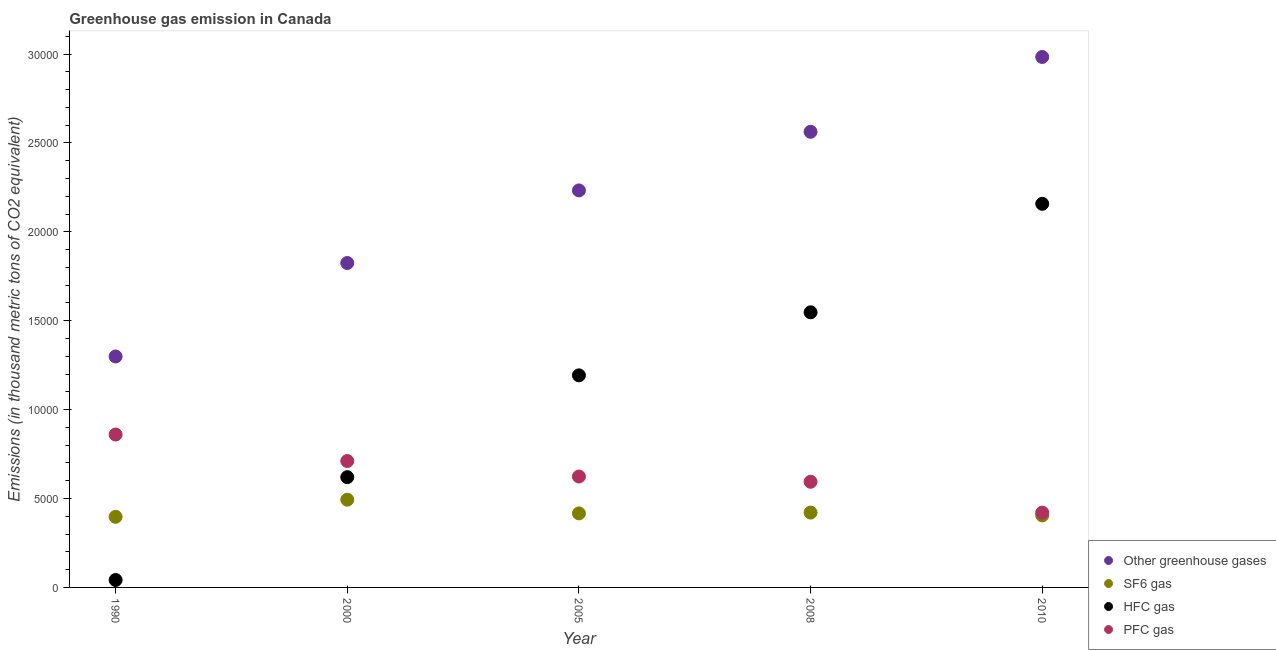How many different coloured dotlines are there?
Your answer should be very brief. 4. What is the emission of greenhouse gases in 2005?
Give a very brief answer. 2.23e+04. Across all years, what is the maximum emission of sf6 gas?
Provide a succinct answer. 4935.1. Across all years, what is the minimum emission of greenhouse gases?
Ensure brevity in your answer.  1.30e+04. In which year was the emission of greenhouse gases maximum?
Make the answer very short. 2010. In which year was the emission of greenhouse gases minimum?
Your answer should be very brief. 1990. What is the total emission of sf6 gas in the graph?
Make the answer very short. 2.13e+04. What is the difference between the emission of sf6 gas in 1990 and that in 2008?
Keep it short and to the point. -237. What is the difference between the emission of hfc gas in 1990 and the emission of sf6 gas in 2008?
Offer a terse response. -3790.3. What is the average emission of hfc gas per year?
Your answer should be very brief. 1.11e+04. In the year 2005, what is the difference between the emission of hfc gas and emission of sf6 gas?
Offer a very short reply. 7764.6. In how many years, is the emission of sf6 gas greater than 28000 thousand metric tons?
Your answer should be compact. 0. What is the ratio of the emission of pfc gas in 1990 to that in 2008?
Your answer should be compact. 1.45. Is the difference between the emission of hfc gas in 1990 and 2000 greater than the difference between the emission of greenhouse gases in 1990 and 2000?
Your answer should be very brief. No. What is the difference between the highest and the second highest emission of sf6 gas?
Ensure brevity in your answer.  726.3. What is the difference between the highest and the lowest emission of hfc gas?
Your answer should be very brief. 2.12e+04. In how many years, is the emission of hfc gas greater than the average emission of hfc gas taken over all years?
Offer a terse response. 3. How many dotlines are there?
Ensure brevity in your answer.  4. How are the legend labels stacked?
Your response must be concise. Vertical. What is the title of the graph?
Your answer should be very brief. Greenhouse gas emission in Canada. What is the label or title of the Y-axis?
Your response must be concise. Emissions (in thousand metric tons of CO2 equivalent). What is the Emissions (in thousand metric tons of CO2 equivalent) in Other greenhouse gases in 1990?
Your answer should be very brief. 1.30e+04. What is the Emissions (in thousand metric tons of CO2 equivalent) in SF6 gas in 1990?
Provide a succinct answer. 3971.8. What is the Emissions (in thousand metric tons of CO2 equivalent) of HFC gas in 1990?
Provide a succinct answer. 418.5. What is the Emissions (in thousand metric tons of CO2 equivalent) of PFC gas in 1990?
Provide a succinct answer. 8600.3. What is the Emissions (in thousand metric tons of CO2 equivalent) of Other greenhouse gases in 2000?
Offer a very short reply. 1.82e+04. What is the Emissions (in thousand metric tons of CO2 equivalent) of SF6 gas in 2000?
Give a very brief answer. 4935.1. What is the Emissions (in thousand metric tons of CO2 equivalent) of HFC gas in 2000?
Keep it short and to the point. 6202.8. What is the Emissions (in thousand metric tons of CO2 equivalent) of PFC gas in 2000?
Your response must be concise. 7109.9. What is the Emissions (in thousand metric tons of CO2 equivalent) in Other greenhouse gases in 2005?
Offer a very short reply. 2.23e+04. What is the Emissions (in thousand metric tons of CO2 equivalent) in SF6 gas in 2005?
Your answer should be very brief. 4163.8. What is the Emissions (in thousand metric tons of CO2 equivalent) of HFC gas in 2005?
Provide a short and direct response. 1.19e+04. What is the Emissions (in thousand metric tons of CO2 equivalent) of PFC gas in 2005?
Keep it short and to the point. 6238. What is the Emissions (in thousand metric tons of CO2 equivalent) in Other greenhouse gases in 2008?
Provide a succinct answer. 2.56e+04. What is the Emissions (in thousand metric tons of CO2 equivalent) of SF6 gas in 2008?
Your answer should be compact. 4208.8. What is the Emissions (in thousand metric tons of CO2 equivalent) of HFC gas in 2008?
Offer a very short reply. 1.55e+04. What is the Emissions (in thousand metric tons of CO2 equivalent) in PFC gas in 2008?
Make the answer very short. 5943.7. What is the Emissions (in thousand metric tons of CO2 equivalent) of Other greenhouse gases in 2010?
Ensure brevity in your answer.  2.98e+04. What is the Emissions (in thousand metric tons of CO2 equivalent) in SF6 gas in 2010?
Your answer should be very brief. 4050. What is the Emissions (in thousand metric tons of CO2 equivalent) of HFC gas in 2010?
Your response must be concise. 2.16e+04. What is the Emissions (in thousand metric tons of CO2 equivalent) in PFC gas in 2010?
Keep it short and to the point. 4209. Across all years, what is the maximum Emissions (in thousand metric tons of CO2 equivalent) in Other greenhouse gases?
Your answer should be very brief. 2.98e+04. Across all years, what is the maximum Emissions (in thousand metric tons of CO2 equivalent) of SF6 gas?
Your answer should be compact. 4935.1. Across all years, what is the maximum Emissions (in thousand metric tons of CO2 equivalent) of HFC gas?
Give a very brief answer. 2.16e+04. Across all years, what is the maximum Emissions (in thousand metric tons of CO2 equivalent) of PFC gas?
Offer a very short reply. 8600.3. Across all years, what is the minimum Emissions (in thousand metric tons of CO2 equivalent) of Other greenhouse gases?
Offer a very short reply. 1.30e+04. Across all years, what is the minimum Emissions (in thousand metric tons of CO2 equivalent) in SF6 gas?
Provide a succinct answer. 3971.8. Across all years, what is the minimum Emissions (in thousand metric tons of CO2 equivalent) in HFC gas?
Your answer should be compact. 418.5. Across all years, what is the minimum Emissions (in thousand metric tons of CO2 equivalent) in PFC gas?
Provide a short and direct response. 4209. What is the total Emissions (in thousand metric tons of CO2 equivalent) in Other greenhouse gases in the graph?
Make the answer very short. 1.09e+05. What is the total Emissions (in thousand metric tons of CO2 equivalent) of SF6 gas in the graph?
Your response must be concise. 2.13e+04. What is the total Emissions (in thousand metric tons of CO2 equivalent) of HFC gas in the graph?
Provide a short and direct response. 5.56e+04. What is the total Emissions (in thousand metric tons of CO2 equivalent) in PFC gas in the graph?
Provide a short and direct response. 3.21e+04. What is the difference between the Emissions (in thousand metric tons of CO2 equivalent) in Other greenhouse gases in 1990 and that in 2000?
Make the answer very short. -5257.2. What is the difference between the Emissions (in thousand metric tons of CO2 equivalent) of SF6 gas in 1990 and that in 2000?
Ensure brevity in your answer.  -963.3. What is the difference between the Emissions (in thousand metric tons of CO2 equivalent) of HFC gas in 1990 and that in 2000?
Your answer should be very brief. -5784.3. What is the difference between the Emissions (in thousand metric tons of CO2 equivalent) in PFC gas in 1990 and that in 2000?
Offer a very short reply. 1490.4. What is the difference between the Emissions (in thousand metric tons of CO2 equivalent) of Other greenhouse gases in 1990 and that in 2005?
Offer a very short reply. -9339.6. What is the difference between the Emissions (in thousand metric tons of CO2 equivalent) in SF6 gas in 1990 and that in 2005?
Make the answer very short. -192. What is the difference between the Emissions (in thousand metric tons of CO2 equivalent) of HFC gas in 1990 and that in 2005?
Your answer should be compact. -1.15e+04. What is the difference between the Emissions (in thousand metric tons of CO2 equivalent) of PFC gas in 1990 and that in 2005?
Your answer should be very brief. 2362.3. What is the difference between the Emissions (in thousand metric tons of CO2 equivalent) in Other greenhouse gases in 1990 and that in 2008?
Provide a short and direct response. -1.26e+04. What is the difference between the Emissions (in thousand metric tons of CO2 equivalent) in SF6 gas in 1990 and that in 2008?
Offer a very short reply. -237. What is the difference between the Emissions (in thousand metric tons of CO2 equivalent) in HFC gas in 1990 and that in 2008?
Keep it short and to the point. -1.51e+04. What is the difference between the Emissions (in thousand metric tons of CO2 equivalent) in PFC gas in 1990 and that in 2008?
Keep it short and to the point. 2656.6. What is the difference between the Emissions (in thousand metric tons of CO2 equivalent) in Other greenhouse gases in 1990 and that in 2010?
Your response must be concise. -1.68e+04. What is the difference between the Emissions (in thousand metric tons of CO2 equivalent) of SF6 gas in 1990 and that in 2010?
Offer a very short reply. -78.2. What is the difference between the Emissions (in thousand metric tons of CO2 equivalent) of HFC gas in 1990 and that in 2010?
Provide a succinct answer. -2.12e+04. What is the difference between the Emissions (in thousand metric tons of CO2 equivalent) of PFC gas in 1990 and that in 2010?
Your answer should be very brief. 4391.3. What is the difference between the Emissions (in thousand metric tons of CO2 equivalent) in Other greenhouse gases in 2000 and that in 2005?
Offer a very short reply. -4082.4. What is the difference between the Emissions (in thousand metric tons of CO2 equivalent) in SF6 gas in 2000 and that in 2005?
Your response must be concise. 771.3. What is the difference between the Emissions (in thousand metric tons of CO2 equivalent) of HFC gas in 2000 and that in 2005?
Offer a terse response. -5725.6. What is the difference between the Emissions (in thousand metric tons of CO2 equivalent) of PFC gas in 2000 and that in 2005?
Give a very brief answer. 871.9. What is the difference between the Emissions (in thousand metric tons of CO2 equivalent) in Other greenhouse gases in 2000 and that in 2008?
Offer a very short reply. -7379.5. What is the difference between the Emissions (in thousand metric tons of CO2 equivalent) of SF6 gas in 2000 and that in 2008?
Your answer should be very brief. 726.3. What is the difference between the Emissions (in thousand metric tons of CO2 equivalent) in HFC gas in 2000 and that in 2008?
Give a very brief answer. -9272. What is the difference between the Emissions (in thousand metric tons of CO2 equivalent) in PFC gas in 2000 and that in 2008?
Give a very brief answer. 1166.2. What is the difference between the Emissions (in thousand metric tons of CO2 equivalent) of Other greenhouse gases in 2000 and that in 2010?
Ensure brevity in your answer.  -1.16e+04. What is the difference between the Emissions (in thousand metric tons of CO2 equivalent) in SF6 gas in 2000 and that in 2010?
Offer a terse response. 885.1. What is the difference between the Emissions (in thousand metric tons of CO2 equivalent) in HFC gas in 2000 and that in 2010?
Your response must be concise. -1.54e+04. What is the difference between the Emissions (in thousand metric tons of CO2 equivalent) in PFC gas in 2000 and that in 2010?
Your answer should be compact. 2900.9. What is the difference between the Emissions (in thousand metric tons of CO2 equivalent) of Other greenhouse gases in 2005 and that in 2008?
Your answer should be very brief. -3297.1. What is the difference between the Emissions (in thousand metric tons of CO2 equivalent) of SF6 gas in 2005 and that in 2008?
Ensure brevity in your answer.  -45. What is the difference between the Emissions (in thousand metric tons of CO2 equivalent) of HFC gas in 2005 and that in 2008?
Provide a short and direct response. -3546.4. What is the difference between the Emissions (in thousand metric tons of CO2 equivalent) of PFC gas in 2005 and that in 2008?
Your answer should be compact. 294.3. What is the difference between the Emissions (in thousand metric tons of CO2 equivalent) of Other greenhouse gases in 2005 and that in 2010?
Offer a terse response. -7505.8. What is the difference between the Emissions (in thousand metric tons of CO2 equivalent) of SF6 gas in 2005 and that in 2010?
Make the answer very short. 113.8. What is the difference between the Emissions (in thousand metric tons of CO2 equivalent) of HFC gas in 2005 and that in 2010?
Make the answer very short. -9648.6. What is the difference between the Emissions (in thousand metric tons of CO2 equivalent) in PFC gas in 2005 and that in 2010?
Keep it short and to the point. 2029. What is the difference between the Emissions (in thousand metric tons of CO2 equivalent) of Other greenhouse gases in 2008 and that in 2010?
Your response must be concise. -4208.7. What is the difference between the Emissions (in thousand metric tons of CO2 equivalent) of SF6 gas in 2008 and that in 2010?
Your response must be concise. 158.8. What is the difference between the Emissions (in thousand metric tons of CO2 equivalent) in HFC gas in 2008 and that in 2010?
Your response must be concise. -6102.2. What is the difference between the Emissions (in thousand metric tons of CO2 equivalent) of PFC gas in 2008 and that in 2010?
Give a very brief answer. 1734.7. What is the difference between the Emissions (in thousand metric tons of CO2 equivalent) in Other greenhouse gases in 1990 and the Emissions (in thousand metric tons of CO2 equivalent) in SF6 gas in 2000?
Your answer should be compact. 8055.5. What is the difference between the Emissions (in thousand metric tons of CO2 equivalent) in Other greenhouse gases in 1990 and the Emissions (in thousand metric tons of CO2 equivalent) in HFC gas in 2000?
Make the answer very short. 6787.8. What is the difference between the Emissions (in thousand metric tons of CO2 equivalent) in Other greenhouse gases in 1990 and the Emissions (in thousand metric tons of CO2 equivalent) in PFC gas in 2000?
Your answer should be compact. 5880.7. What is the difference between the Emissions (in thousand metric tons of CO2 equivalent) in SF6 gas in 1990 and the Emissions (in thousand metric tons of CO2 equivalent) in HFC gas in 2000?
Ensure brevity in your answer.  -2231. What is the difference between the Emissions (in thousand metric tons of CO2 equivalent) of SF6 gas in 1990 and the Emissions (in thousand metric tons of CO2 equivalent) of PFC gas in 2000?
Offer a terse response. -3138.1. What is the difference between the Emissions (in thousand metric tons of CO2 equivalent) of HFC gas in 1990 and the Emissions (in thousand metric tons of CO2 equivalent) of PFC gas in 2000?
Your answer should be very brief. -6691.4. What is the difference between the Emissions (in thousand metric tons of CO2 equivalent) of Other greenhouse gases in 1990 and the Emissions (in thousand metric tons of CO2 equivalent) of SF6 gas in 2005?
Offer a very short reply. 8826.8. What is the difference between the Emissions (in thousand metric tons of CO2 equivalent) of Other greenhouse gases in 1990 and the Emissions (in thousand metric tons of CO2 equivalent) of HFC gas in 2005?
Ensure brevity in your answer.  1062.2. What is the difference between the Emissions (in thousand metric tons of CO2 equivalent) of Other greenhouse gases in 1990 and the Emissions (in thousand metric tons of CO2 equivalent) of PFC gas in 2005?
Provide a succinct answer. 6752.6. What is the difference between the Emissions (in thousand metric tons of CO2 equivalent) of SF6 gas in 1990 and the Emissions (in thousand metric tons of CO2 equivalent) of HFC gas in 2005?
Your answer should be compact. -7956.6. What is the difference between the Emissions (in thousand metric tons of CO2 equivalent) of SF6 gas in 1990 and the Emissions (in thousand metric tons of CO2 equivalent) of PFC gas in 2005?
Make the answer very short. -2266.2. What is the difference between the Emissions (in thousand metric tons of CO2 equivalent) in HFC gas in 1990 and the Emissions (in thousand metric tons of CO2 equivalent) in PFC gas in 2005?
Offer a very short reply. -5819.5. What is the difference between the Emissions (in thousand metric tons of CO2 equivalent) in Other greenhouse gases in 1990 and the Emissions (in thousand metric tons of CO2 equivalent) in SF6 gas in 2008?
Provide a short and direct response. 8781.8. What is the difference between the Emissions (in thousand metric tons of CO2 equivalent) of Other greenhouse gases in 1990 and the Emissions (in thousand metric tons of CO2 equivalent) of HFC gas in 2008?
Offer a terse response. -2484.2. What is the difference between the Emissions (in thousand metric tons of CO2 equivalent) in Other greenhouse gases in 1990 and the Emissions (in thousand metric tons of CO2 equivalent) in PFC gas in 2008?
Your answer should be very brief. 7046.9. What is the difference between the Emissions (in thousand metric tons of CO2 equivalent) in SF6 gas in 1990 and the Emissions (in thousand metric tons of CO2 equivalent) in HFC gas in 2008?
Give a very brief answer. -1.15e+04. What is the difference between the Emissions (in thousand metric tons of CO2 equivalent) of SF6 gas in 1990 and the Emissions (in thousand metric tons of CO2 equivalent) of PFC gas in 2008?
Your response must be concise. -1971.9. What is the difference between the Emissions (in thousand metric tons of CO2 equivalent) of HFC gas in 1990 and the Emissions (in thousand metric tons of CO2 equivalent) of PFC gas in 2008?
Make the answer very short. -5525.2. What is the difference between the Emissions (in thousand metric tons of CO2 equivalent) in Other greenhouse gases in 1990 and the Emissions (in thousand metric tons of CO2 equivalent) in SF6 gas in 2010?
Your answer should be compact. 8940.6. What is the difference between the Emissions (in thousand metric tons of CO2 equivalent) of Other greenhouse gases in 1990 and the Emissions (in thousand metric tons of CO2 equivalent) of HFC gas in 2010?
Make the answer very short. -8586.4. What is the difference between the Emissions (in thousand metric tons of CO2 equivalent) in Other greenhouse gases in 1990 and the Emissions (in thousand metric tons of CO2 equivalent) in PFC gas in 2010?
Ensure brevity in your answer.  8781.6. What is the difference between the Emissions (in thousand metric tons of CO2 equivalent) in SF6 gas in 1990 and the Emissions (in thousand metric tons of CO2 equivalent) in HFC gas in 2010?
Offer a very short reply. -1.76e+04. What is the difference between the Emissions (in thousand metric tons of CO2 equivalent) in SF6 gas in 1990 and the Emissions (in thousand metric tons of CO2 equivalent) in PFC gas in 2010?
Keep it short and to the point. -237.2. What is the difference between the Emissions (in thousand metric tons of CO2 equivalent) of HFC gas in 1990 and the Emissions (in thousand metric tons of CO2 equivalent) of PFC gas in 2010?
Your answer should be compact. -3790.5. What is the difference between the Emissions (in thousand metric tons of CO2 equivalent) of Other greenhouse gases in 2000 and the Emissions (in thousand metric tons of CO2 equivalent) of SF6 gas in 2005?
Offer a very short reply. 1.41e+04. What is the difference between the Emissions (in thousand metric tons of CO2 equivalent) in Other greenhouse gases in 2000 and the Emissions (in thousand metric tons of CO2 equivalent) in HFC gas in 2005?
Your answer should be compact. 6319.4. What is the difference between the Emissions (in thousand metric tons of CO2 equivalent) in Other greenhouse gases in 2000 and the Emissions (in thousand metric tons of CO2 equivalent) in PFC gas in 2005?
Offer a terse response. 1.20e+04. What is the difference between the Emissions (in thousand metric tons of CO2 equivalent) in SF6 gas in 2000 and the Emissions (in thousand metric tons of CO2 equivalent) in HFC gas in 2005?
Provide a succinct answer. -6993.3. What is the difference between the Emissions (in thousand metric tons of CO2 equivalent) of SF6 gas in 2000 and the Emissions (in thousand metric tons of CO2 equivalent) of PFC gas in 2005?
Keep it short and to the point. -1302.9. What is the difference between the Emissions (in thousand metric tons of CO2 equivalent) of HFC gas in 2000 and the Emissions (in thousand metric tons of CO2 equivalent) of PFC gas in 2005?
Give a very brief answer. -35.2. What is the difference between the Emissions (in thousand metric tons of CO2 equivalent) in Other greenhouse gases in 2000 and the Emissions (in thousand metric tons of CO2 equivalent) in SF6 gas in 2008?
Provide a succinct answer. 1.40e+04. What is the difference between the Emissions (in thousand metric tons of CO2 equivalent) of Other greenhouse gases in 2000 and the Emissions (in thousand metric tons of CO2 equivalent) of HFC gas in 2008?
Your response must be concise. 2773. What is the difference between the Emissions (in thousand metric tons of CO2 equivalent) of Other greenhouse gases in 2000 and the Emissions (in thousand metric tons of CO2 equivalent) of PFC gas in 2008?
Your response must be concise. 1.23e+04. What is the difference between the Emissions (in thousand metric tons of CO2 equivalent) of SF6 gas in 2000 and the Emissions (in thousand metric tons of CO2 equivalent) of HFC gas in 2008?
Your answer should be very brief. -1.05e+04. What is the difference between the Emissions (in thousand metric tons of CO2 equivalent) of SF6 gas in 2000 and the Emissions (in thousand metric tons of CO2 equivalent) of PFC gas in 2008?
Offer a very short reply. -1008.6. What is the difference between the Emissions (in thousand metric tons of CO2 equivalent) of HFC gas in 2000 and the Emissions (in thousand metric tons of CO2 equivalent) of PFC gas in 2008?
Offer a very short reply. 259.1. What is the difference between the Emissions (in thousand metric tons of CO2 equivalent) of Other greenhouse gases in 2000 and the Emissions (in thousand metric tons of CO2 equivalent) of SF6 gas in 2010?
Your answer should be compact. 1.42e+04. What is the difference between the Emissions (in thousand metric tons of CO2 equivalent) of Other greenhouse gases in 2000 and the Emissions (in thousand metric tons of CO2 equivalent) of HFC gas in 2010?
Give a very brief answer. -3329.2. What is the difference between the Emissions (in thousand metric tons of CO2 equivalent) of Other greenhouse gases in 2000 and the Emissions (in thousand metric tons of CO2 equivalent) of PFC gas in 2010?
Provide a short and direct response. 1.40e+04. What is the difference between the Emissions (in thousand metric tons of CO2 equivalent) of SF6 gas in 2000 and the Emissions (in thousand metric tons of CO2 equivalent) of HFC gas in 2010?
Offer a very short reply. -1.66e+04. What is the difference between the Emissions (in thousand metric tons of CO2 equivalent) of SF6 gas in 2000 and the Emissions (in thousand metric tons of CO2 equivalent) of PFC gas in 2010?
Offer a terse response. 726.1. What is the difference between the Emissions (in thousand metric tons of CO2 equivalent) in HFC gas in 2000 and the Emissions (in thousand metric tons of CO2 equivalent) in PFC gas in 2010?
Provide a succinct answer. 1993.8. What is the difference between the Emissions (in thousand metric tons of CO2 equivalent) in Other greenhouse gases in 2005 and the Emissions (in thousand metric tons of CO2 equivalent) in SF6 gas in 2008?
Provide a short and direct response. 1.81e+04. What is the difference between the Emissions (in thousand metric tons of CO2 equivalent) of Other greenhouse gases in 2005 and the Emissions (in thousand metric tons of CO2 equivalent) of HFC gas in 2008?
Offer a terse response. 6855.4. What is the difference between the Emissions (in thousand metric tons of CO2 equivalent) in Other greenhouse gases in 2005 and the Emissions (in thousand metric tons of CO2 equivalent) in PFC gas in 2008?
Offer a terse response. 1.64e+04. What is the difference between the Emissions (in thousand metric tons of CO2 equivalent) of SF6 gas in 2005 and the Emissions (in thousand metric tons of CO2 equivalent) of HFC gas in 2008?
Ensure brevity in your answer.  -1.13e+04. What is the difference between the Emissions (in thousand metric tons of CO2 equivalent) in SF6 gas in 2005 and the Emissions (in thousand metric tons of CO2 equivalent) in PFC gas in 2008?
Ensure brevity in your answer.  -1779.9. What is the difference between the Emissions (in thousand metric tons of CO2 equivalent) in HFC gas in 2005 and the Emissions (in thousand metric tons of CO2 equivalent) in PFC gas in 2008?
Offer a terse response. 5984.7. What is the difference between the Emissions (in thousand metric tons of CO2 equivalent) in Other greenhouse gases in 2005 and the Emissions (in thousand metric tons of CO2 equivalent) in SF6 gas in 2010?
Your response must be concise. 1.83e+04. What is the difference between the Emissions (in thousand metric tons of CO2 equivalent) in Other greenhouse gases in 2005 and the Emissions (in thousand metric tons of CO2 equivalent) in HFC gas in 2010?
Your answer should be very brief. 753.2. What is the difference between the Emissions (in thousand metric tons of CO2 equivalent) of Other greenhouse gases in 2005 and the Emissions (in thousand metric tons of CO2 equivalent) of PFC gas in 2010?
Keep it short and to the point. 1.81e+04. What is the difference between the Emissions (in thousand metric tons of CO2 equivalent) in SF6 gas in 2005 and the Emissions (in thousand metric tons of CO2 equivalent) in HFC gas in 2010?
Offer a terse response. -1.74e+04. What is the difference between the Emissions (in thousand metric tons of CO2 equivalent) in SF6 gas in 2005 and the Emissions (in thousand metric tons of CO2 equivalent) in PFC gas in 2010?
Your answer should be compact. -45.2. What is the difference between the Emissions (in thousand metric tons of CO2 equivalent) in HFC gas in 2005 and the Emissions (in thousand metric tons of CO2 equivalent) in PFC gas in 2010?
Your response must be concise. 7719.4. What is the difference between the Emissions (in thousand metric tons of CO2 equivalent) of Other greenhouse gases in 2008 and the Emissions (in thousand metric tons of CO2 equivalent) of SF6 gas in 2010?
Provide a short and direct response. 2.16e+04. What is the difference between the Emissions (in thousand metric tons of CO2 equivalent) in Other greenhouse gases in 2008 and the Emissions (in thousand metric tons of CO2 equivalent) in HFC gas in 2010?
Keep it short and to the point. 4050.3. What is the difference between the Emissions (in thousand metric tons of CO2 equivalent) of Other greenhouse gases in 2008 and the Emissions (in thousand metric tons of CO2 equivalent) of PFC gas in 2010?
Offer a terse response. 2.14e+04. What is the difference between the Emissions (in thousand metric tons of CO2 equivalent) of SF6 gas in 2008 and the Emissions (in thousand metric tons of CO2 equivalent) of HFC gas in 2010?
Ensure brevity in your answer.  -1.74e+04. What is the difference between the Emissions (in thousand metric tons of CO2 equivalent) of HFC gas in 2008 and the Emissions (in thousand metric tons of CO2 equivalent) of PFC gas in 2010?
Offer a very short reply. 1.13e+04. What is the average Emissions (in thousand metric tons of CO2 equivalent) of Other greenhouse gases per year?
Your answer should be compact. 2.18e+04. What is the average Emissions (in thousand metric tons of CO2 equivalent) of SF6 gas per year?
Keep it short and to the point. 4265.9. What is the average Emissions (in thousand metric tons of CO2 equivalent) in HFC gas per year?
Keep it short and to the point. 1.11e+04. What is the average Emissions (in thousand metric tons of CO2 equivalent) of PFC gas per year?
Ensure brevity in your answer.  6420.18. In the year 1990, what is the difference between the Emissions (in thousand metric tons of CO2 equivalent) in Other greenhouse gases and Emissions (in thousand metric tons of CO2 equivalent) in SF6 gas?
Make the answer very short. 9018.8. In the year 1990, what is the difference between the Emissions (in thousand metric tons of CO2 equivalent) of Other greenhouse gases and Emissions (in thousand metric tons of CO2 equivalent) of HFC gas?
Ensure brevity in your answer.  1.26e+04. In the year 1990, what is the difference between the Emissions (in thousand metric tons of CO2 equivalent) of Other greenhouse gases and Emissions (in thousand metric tons of CO2 equivalent) of PFC gas?
Make the answer very short. 4390.3. In the year 1990, what is the difference between the Emissions (in thousand metric tons of CO2 equivalent) of SF6 gas and Emissions (in thousand metric tons of CO2 equivalent) of HFC gas?
Your answer should be compact. 3553.3. In the year 1990, what is the difference between the Emissions (in thousand metric tons of CO2 equivalent) in SF6 gas and Emissions (in thousand metric tons of CO2 equivalent) in PFC gas?
Your response must be concise. -4628.5. In the year 1990, what is the difference between the Emissions (in thousand metric tons of CO2 equivalent) in HFC gas and Emissions (in thousand metric tons of CO2 equivalent) in PFC gas?
Your answer should be compact. -8181.8. In the year 2000, what is the difference between the Emissions (in thousand metric tons of CO2 equivalent) of Other greenhouse gases and Emissions (in thousand metric tons of CO2 equivalent) of SF6 gas?
Your answer should be compact. 1.33e+04. In the year 2000, what is the difference between the Emissions (in thousand metric tons of CO2 equivalent) of Other greenhouse gases and Emissions (in thousand metric tons of CO2 equivalent) of HFC gas?
Offer a terse response. 1.20e+04. In the year 2000, what is the difference between the Emissions (in thousand metric tons of CO2 equivalent) in Other greenhouse gases and Emissions (in thousand metric tons of CO2 equivalent) in PFC gas?
Ensure brevity in your answer.  1.11e+04. In the year 2000, what is the difference between the Emissions (in thousand metric tons of CO2 equivalent) of SF6 gas and Emissions (in thousand metric tons of CO2 equivalent) of HFC gas?
Provide a short and direct response. -1267.7. In the year 2000, what is the difference between the Emissions (in thousand metric tons of CO2 equivalent) of SF6 gas and Emissions (in thousand metric tons of CO2 equivalent) of PFC gas?
Provide a succinct answer. -2174.8. In the year 2000, what is the difference between the Emissions (in thousand metric tons of CO2 equivalent) in HFC gas and Emissions (in thousand metric tons of CO2 equivalent) in PFC gas?
Offer a very short reply. -907.1. In the year 2005, what is the difference between the Emissions (in thousand metric tons of CO2 equivalent) in Other greenhouse gases and Emissions (in thousand metric tons of CO2 equivalent) in SF6 gas?
Your answer should be compact. 1.82e+04. In the year 2005, what is the difference between the Emissions (in thousand metric tons of CO2 equivalent) in Other greenhouse gases and Emissions (in thousand metric tons of CO2 equivalent) in HFC gas?
Keep it short and to the point. 1.04e+04. In the year 2005, what is the difference between the Emissions (in thousand metric tons of CO2 equivalent) in Other greenhouse gases and Emissions (in thousand metric tons of CO2 equivalent) in PFC gas?
Provide a short and direct response. 1.61e+04. In the year 2005, what is the difference between the Emissions (in thousand metric tons of CO2 equivalent) in SF6 gas and Emissions (in thousand metric tons of CO2 equivalent) in HFC gas?
Give a very brief answer. -7764.6. In the year 2005, what is the difference between the Emissions (in thousand metric tons of CO2 equivalent) in SF6 gas and Emissions (in thousand metric tons of CO2 equivalent) in PFC gas?
Provide a short and direct response. -2074.2. In the year 2005, what is the difference between the Emissions (in thousand metric tons of CO2 equivalent) of HFC gas and Emissions (in thousand metric tons of CO2 equivalent) of PFC gas?
Offer a very short reply. 5690.4. In the year 2008, what is the difference between the Emissions (in thousand metric tons of CO2 equivalent) in Other greenhouse gases and Emissions (in thousand metric tons of CO2 equivalent) in SF6 gas?
Offer a very short reply. 2.14e+04. In the year 2008, what is the difference between the Emissions (in thousand metric tons of CO2 equivalent) of Other greenhouse gases and Emissions (in thousand metric tons of CO2 equivalent) of HFC gas?
Provide a succinct answer. 1.02e+04. In the year 2008, what is the difference between the Emissions (in thousand metric tons of CO2 equivalent) in Other greenhouse gases and Emissions (in thousand metric tons of CO2 equivalent) in PFC gas?
Offer a terse response. 1.97e+04. In the year 2008, what is the difference between the Emissions (in thousand metric tons of CO2 equivalent) in SF6 gas and Emissions (in thousand metric tons of CO2 equivalent) in HFC gas?
Keep it short and to the point. -1.13e+04. In the year 2008, what is the difference between the Emissions (in thousand metric tons of CO2 equivalent) of SF6 gas and Emissions (in thousand metric tons of CO2 equivalent) of PFC gas?
Offer a terse response. -1734.9. In the year 2008, what is the difference between the Emissions (in thousand metric tons of CO2 equivalent) of HFC gas and Emissions (in thousand metric tons of CO2 equivalent) of PFC gas?
Offer a very short reply. 9531.1. In the year 2010, what is the difference between the Emissions (in thousand metric tons of CO2 equivalent) in Other greenhouse gases and Emissions (in thousand metric tons of CO2 equivalent) in SF6 gas?
Offer a very short reply. 2.58e+04. In the year 2010, what is the difference between the Emissions (in thousand metric tons of CO2 equivalent) of Other greenhouse gases and Emissions (in thousand metric tons of CO2 equivalent) of HFC gas?
Give a very brief answer. 8259. In the year 2010, what is the difference between the Emissions (in thousand metric tons of CO2 equivalent) of Other greenhouse gases and Emissions (in thousand metric tons of CO2 equivalent) of PFC gas?
Your answer should be compact. 2.56e+04. In the year 2010, what is the difference between the Emissions (in thousand metric tons of CO2 equivalent) in SF6 gas and Emissions (in thousand metric tons of CO2 equivalent) in HFC gas?
Provide a short and direct response. -1.75e+04. In the year 2010, what is the difference between the Emissions (in thousand metric tons of CO2 equivalent) of SF6 gas and Emissions (in thousand metric tons of CO2 equivalent) of PFC gas?
Make the answer very short. -159. In the year 2010, what is the difference between the Emissions (in thousand metric tons of CO2 equivalent) of HFC gas and Emissions (in thousand metric tons of CO2 equivalent) of PFC gas?
Your answer should be very brief. 1.74e+04. What is the ratio of the Emissions (in thousand metric tons of CO2 equivalent) of Other greenhouse gases in 1990 to that in 2000?
Your answer should be very brief. 0.71. What is the ratio of the Emissions (in thousand metric tons of CO2 equivalent) in SF6 gas in 1990 to that in 2000?
Your answer should be compact. 0.8. What is the ratio of the Emissions (in thousand metric tons of CO2 equivalent) of HFC gas in 1990 to that in 2000?
Provide a succinct answer. 0.07. What is the ratio of the Emissions (in thousand metric tons of CO2 equivalent) in PFC gas in 1990 to that in 2000?
Your answer should be very brief. 1.21. What is the ratio of the Emissions (in thousand metric tons of CO2 equivalent) in Other greenhouse gases in 1990 to that in 2005?
Your answer should be very brief. 0.58. What is the ratio of the Emissions (in thousand metric tons of CO2 equivalent) of SF6 gas in 1990 to that in 2005?
Your response must be concise. 0.95. What is the ratio of the Emissions (in thousand metric tons of CO2 equivalent) in HFC gas in 1990 to that in 2005?
Make the answer very short. 0.04. What is the ratio of the Emissions (in thousand metric tons of CO2 equivalent) in PFC gas in 1990 to that in 2005?
Your response must be concise. 1.38. What is the ratio of the Emissions (in thousand metric tons of CO2 equivalent) of Other greenhouse gases in 1990 to that in 2008?
Provide a short and direct response. 0.51. What is the ratio of the Emissions (in thousand metric tons of CO2 equivalent) in SF6 gas in 1990 to that in 2008?
Provide a short and direct response. 0.94. What is the ratio of the Emissions (in thousand metric tons of CO2 equivalent) of HFC gas in 1990 to that in 2008?
Give a very brief answer. 0.03. What is the ratio of the Emissions (in thousand metric tons of CO2 equivalent) of PFC gas in 1990 to that in 2008?
Provide a succinct answer. 1.45. What is the ratio of the Emissions (in thousand metric tons of CO2 equivalent) in Other greenhouse gases in 1990 to that in 2010?
Offer a very short reply. 0.44. What is the ratio of the Emissions (in thousand metric tons of CO2 equivalent) of SF6 gas in 1990 to that in 2010?
Your answer should be compact. 0.98. What is the ratio of the Emissions (in thousand metric tons of CO2 equivalent) in HFC gas in 1990 to that in 2010?
Keep it short and to the point. 0.02. What is the ratio of the Emissions (in thousand metric tons of CO2 equivalent) of PFC gas in 1990 to that in 2010?
Ensure brevity in your answer.  2.04. What is the ratio of the Emissions (in thousand metric tons of CO2 equivalent) of Other greenhouse gases in 2000 to that in 2005?
Your response must be concise. 0.82. What is the ratio of the Emissions (in thousand metric tons of CO2 equivalent) in SF6 gas in 2000 to that in 2005?
Provide a succinct answer. 1.19. What is the ratio of the Emissions (in thousand metric tons of CO2 equivalent) of HFC gas in 2000 to that in 2005?
Provide a short and direct response. 0.52. What is the ratio of the Emissions (in thousand metric tons of CO2 equivalent) of PFC gas in 2000 to that in 2005?
Make the answer very short. 1.14. What is the ratio of the Emissions (in thousand metric tons of CO2 equivalent) in Other greenhouse gases in 2000 to that in 2008?
Provide a succinct answer. 0.71. What is the ratio of the Emissions (in thousand metric tons of CO2 equivalent) in SF6 gas in 2000 to that in 2008?
Provide a succinct answer. 1.17. What is the ratio of the Emissions (in thousand metric tons of CO2 equivalent) in HFC gas in 2000 to that in 2008?
Give a very brief answer. 0.4. What is the ratio of the Emissions (in thousand metric tons of CO2 equivalent) of PFC gas in 2000 to that in 2008?
Provide a succinct answer. 1.2. What is the ratio of the Emissions (in thousand metric tons of CO2 equivalent) in Other greenhouse gases in 2000 to that in 2010?
Make the answer very short. 0.61. What is the ratio of the Emissions (in thousand metric tons of CO2 equivalent) in SF6 gas in 2000 to that in 2010?
Offer a very short reply. 1.22. What is the ratio of the Emissions (in thousand metric tons of CO2 equivalent) in HFC gas in 2000 to that in 2010?
Your answer should be compact. 0.29. What is the ratio of the Emissions (in thousand metric tons of CO2 equivalent) of PFC gas in 2000 to that in 2010?
Provide a short and direct response. 1.69. What is the ratio of the Emissions (in thousand metric tons of CO2 equivalent) of Other greenhouse gases in 2005 to that in 2008?
Ensure brevity in your answer.  0.87. What is the ratio of the Emissions (in thousand metric tons of CO2 equivalent) in SF6 gas in 2005 to that in 2008?
Offer a very short reply. 0.99. What is the ratio of the Emissions (in thousand metric tons of CO2 equivalent) of HFC gas in 2005 to that in 2008?
Offer a terse response. 0.77. What is the ratio of the Emissions (in thousand metric tons of CO2 equivalent) of PFC gas in 2005 to that in 2008?
Your answer should be compact. 1.05. What is the ratio of the Emissions (in thousand metric tons of CO2 equivalent) in Other greenhouse gases in 2005 to that in 2010?
Keep it short and to the point. 0.75. What is the ratio of the Emissions (in thousand metric tons of CO2 equivalent) in SF6 gas in 2005 to that in 2010?
Keep it short and to the point. 1.03. What is the ratio of the Emissions (in thousand metric tons of CO2 equivalent) of HFC gas in 2005 to that in 2010?
Give a very brief answer. 0.55. What is the ratio of the Emissions (in thousand metric tons of CO2 equivalent) of PFC gas in 2005 to that in 2010?
Your response must be concise. 1.48. What is the ratio of the Emissions (in thousand metric tons of CO2 equivalent) of Other greenhouse gases in 2008 to that in 2010?
Keep it short and to the point. 0.86. What is the ratio of the Emissions (in thousand metric tons of CO2 equivalent) of SF6 gas in 2008 to that in 2010?
Make the answer very short. 1.04. What is the ratio of the Emissions (in thousand metric tons of CO2 equivalent) in HFC gas in 2008 to that in 2010?
Offer a very short reply. 0.72. What is the ratio of the Emissions (in thousand metric tons of CO2 equivalent) in PFC gas in 2008 to that in 2010?
Offer a terse response. 1.41. What is the difference between the highest and the second highest Emissions (in thousand metric tons of CO2 equivalent) in Other greenhouse gases?
Your answer should be very brief. 4208.7. What is the difference between the highest and the second highest Emissions (in thousand metric tons of CO2 equivalent) of SF6 gas?
Offer a very short reply. 726.3. What is the difference between the highest and the second highest Emissions (in thousand metric tons of CO2 equivalent) of HFC gas?
Your response must be concise. 6102.2. What is the difference between the highest and the second highest Emissions (in thousand metric tons of CO2 equivalent) in PFC gas?
Your answer should be compact. 1490.4. What is the difference between the highest and the lowest Emissions (in thousand metric tons of CO2 equivalent) in Other greenhouse gases?
Your answer should be very brief. 1.68e+04. What is the difference between the highest and the lowest Emissions (in thousand metric tons of CO2 equivalent) in SF6 gas?
Keep it short and to the point. 963.3. What is the difference between the highest and the lowest Emissions (in thousand metric tons of CO2 equivalent) in HFC gas?
Provide a short and direct response. 2.12e+04. What is the difference between the highest and the lowest Emissions (in thousand metric tons of CO2 equivalent) of PFC gas?
Your answer should be very brief. 4391.3. 